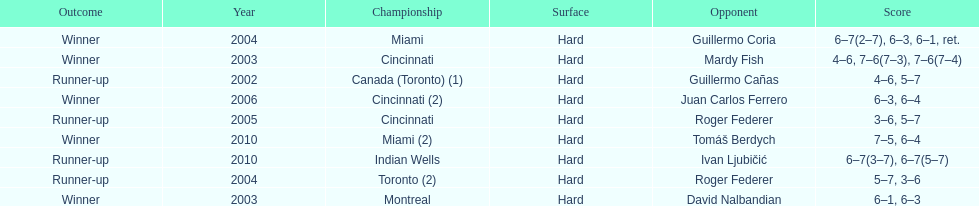How many times were roddick's opponents not from the usa? 8. 